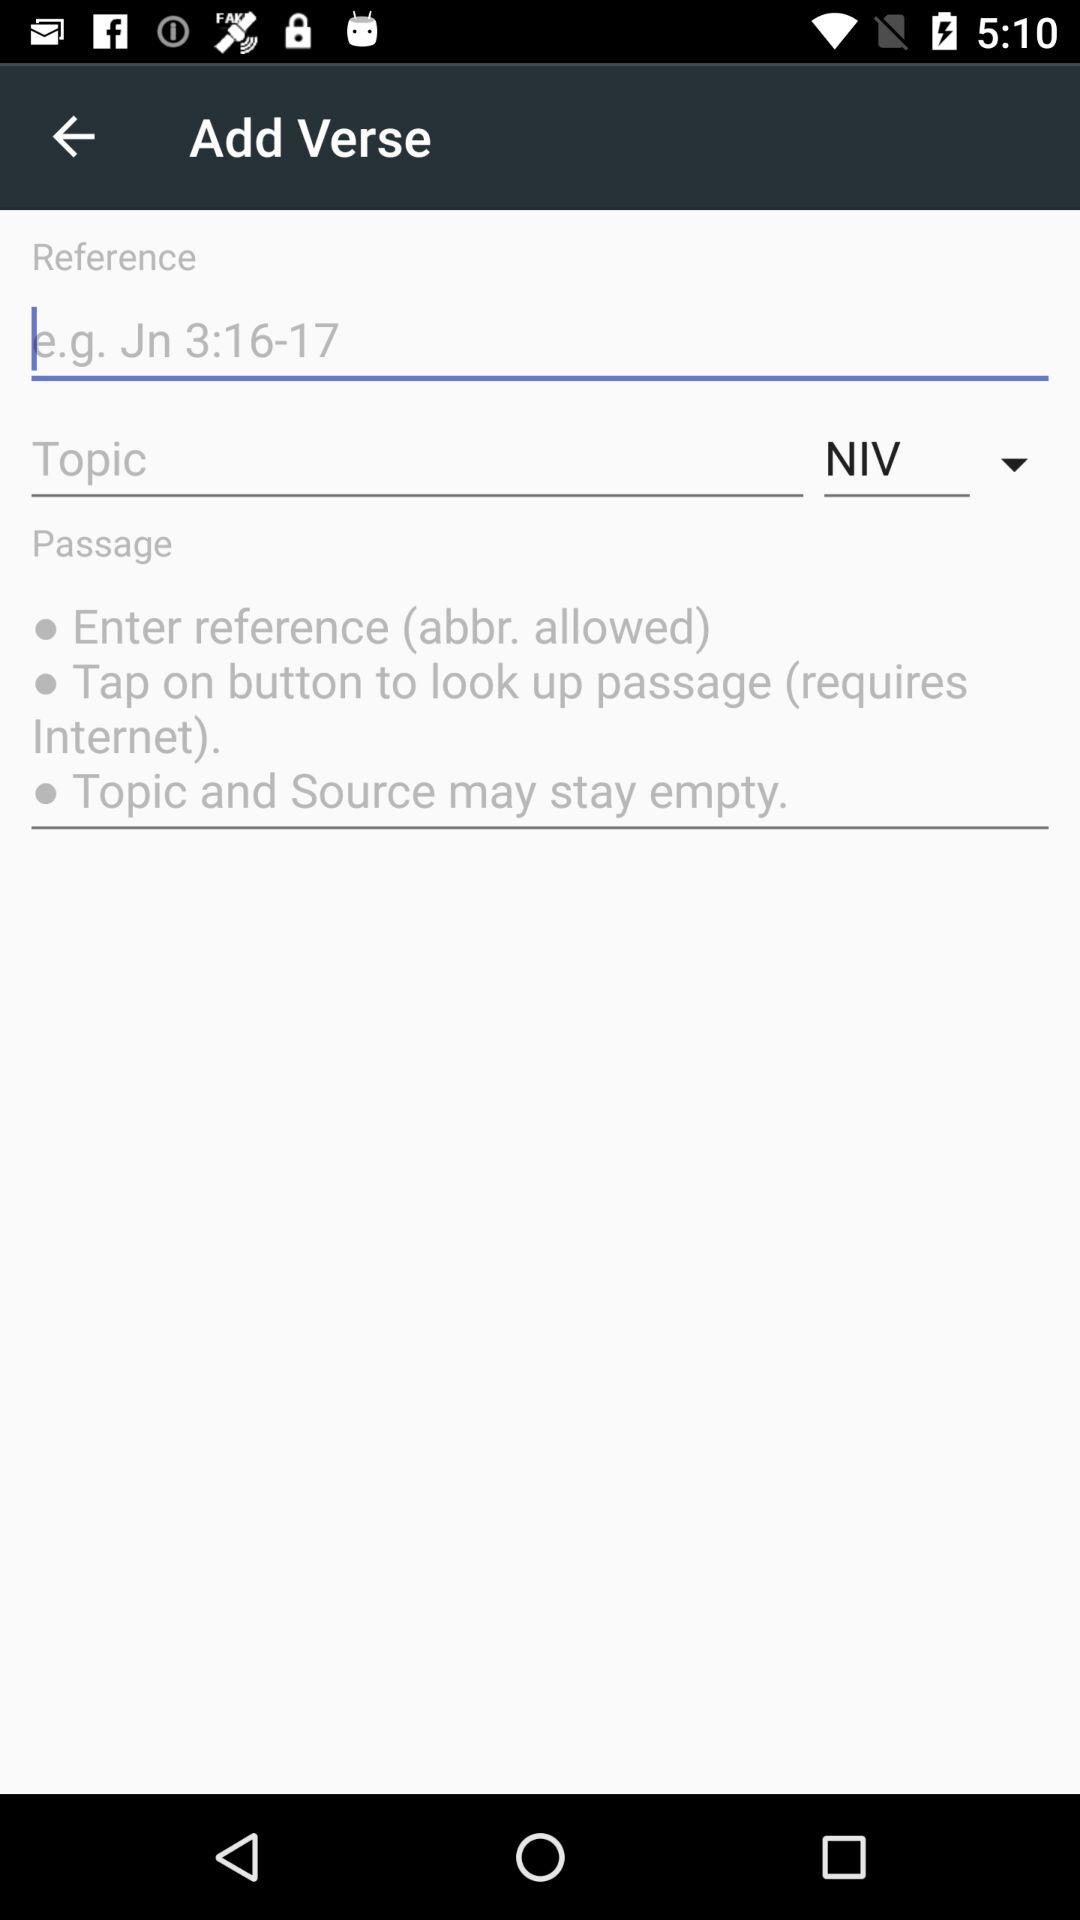What is the topic?
When the provided information is insufficient, respond with <no answer>. <no answer> 